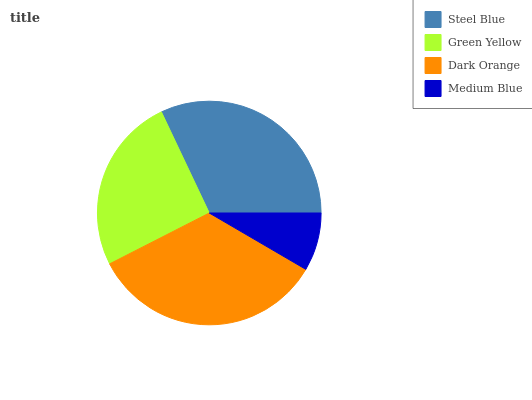Is Medium Blue the minimum?
Answer yes or no. Yes. Is Dark Orange the maximum?
Answer yes or no. Yes. Is Green Yellow the minimum?
Answer yes or no. No. Is Green Yellow the maximum?
Answer yes or no. No. Is Steel Blue greater than Green Yellow?
Answer yes or no. Yes. Is Green Yellow less than Steel Blue?
Answer yes or no. Yes. Is Green Yellow greater than Steel Blue?
Answer yes or no. No. Is Steel Blue less than Green Yellow?
Answer yes or no. No. Is Steel Blue the high median?
Answer yes or no. Yes. Is Green Yellow the low median?
Answer yes or no. Yes. Is Dark Orange the high median?
Answer yes or no. No. Is Steel Blue the low median?
Answer yes or no. No. 